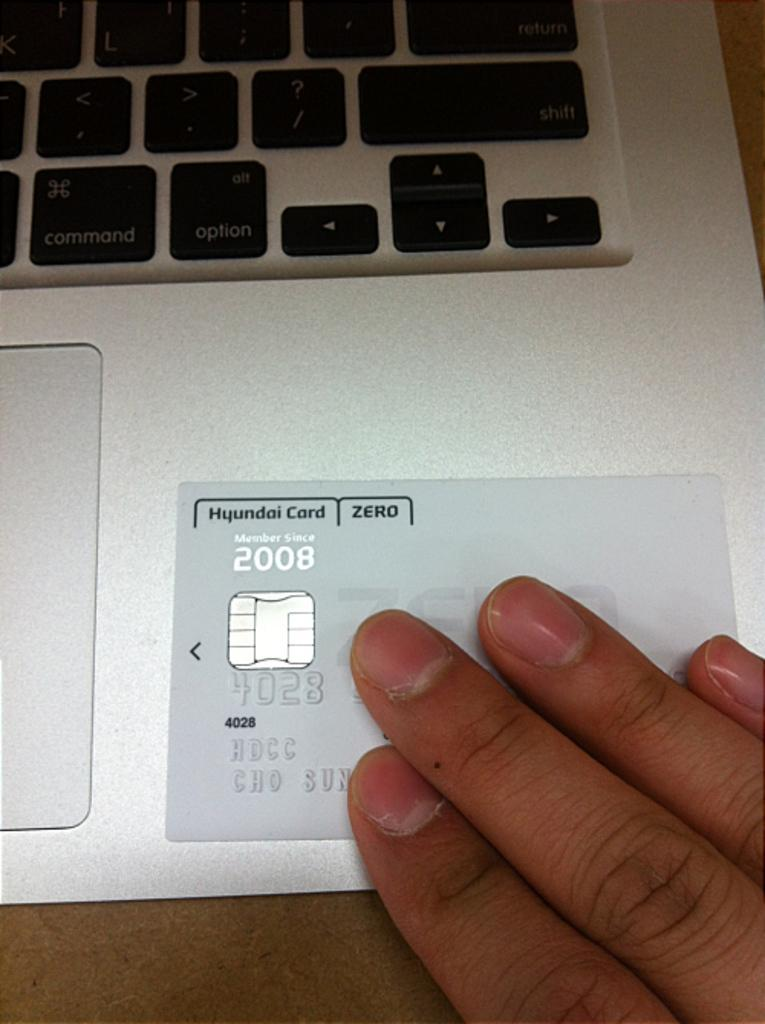<image>
Share a concise interpretation of the image provided. A person holding a Hyundai credit card on a laptop. 